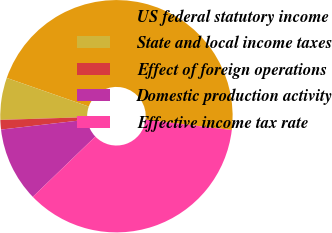Convert chart. <chart><loc_0><loc_0><loc_500><loc_500><pie_chart><fcel>US federal statutory income<fcel>State and local income taxes<fcel>Effect of foreign operations<fcel>Domestic production activity<fcel>Effective income tax rate<nl><fcel>46.54%<fcel>5.85%<fcel>1.33%<fcel>10.37%<fcel>35.9%<nl></chart> 